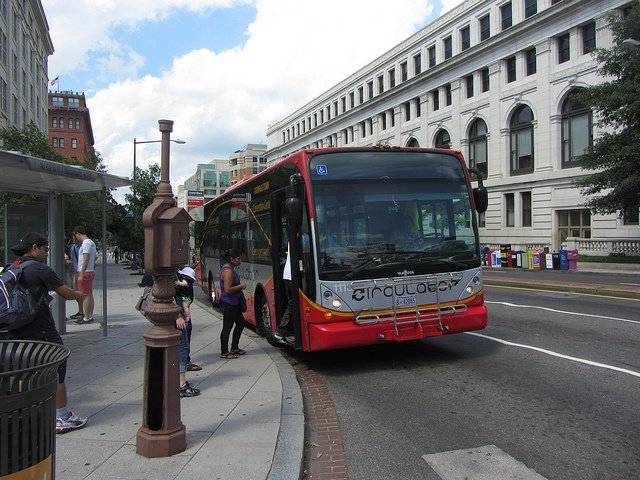Describe the objects in this image and their specific colors. I can see bus in purple, black, gray, darkblue, and blue tones, people in purple, black, gray, and maroon tones, people in purple, black, maroon, brown, and gray tones, backpack in purple, black, gray, and darkblue tones, and people in purple, gray, maroon, and black tones in this image. 